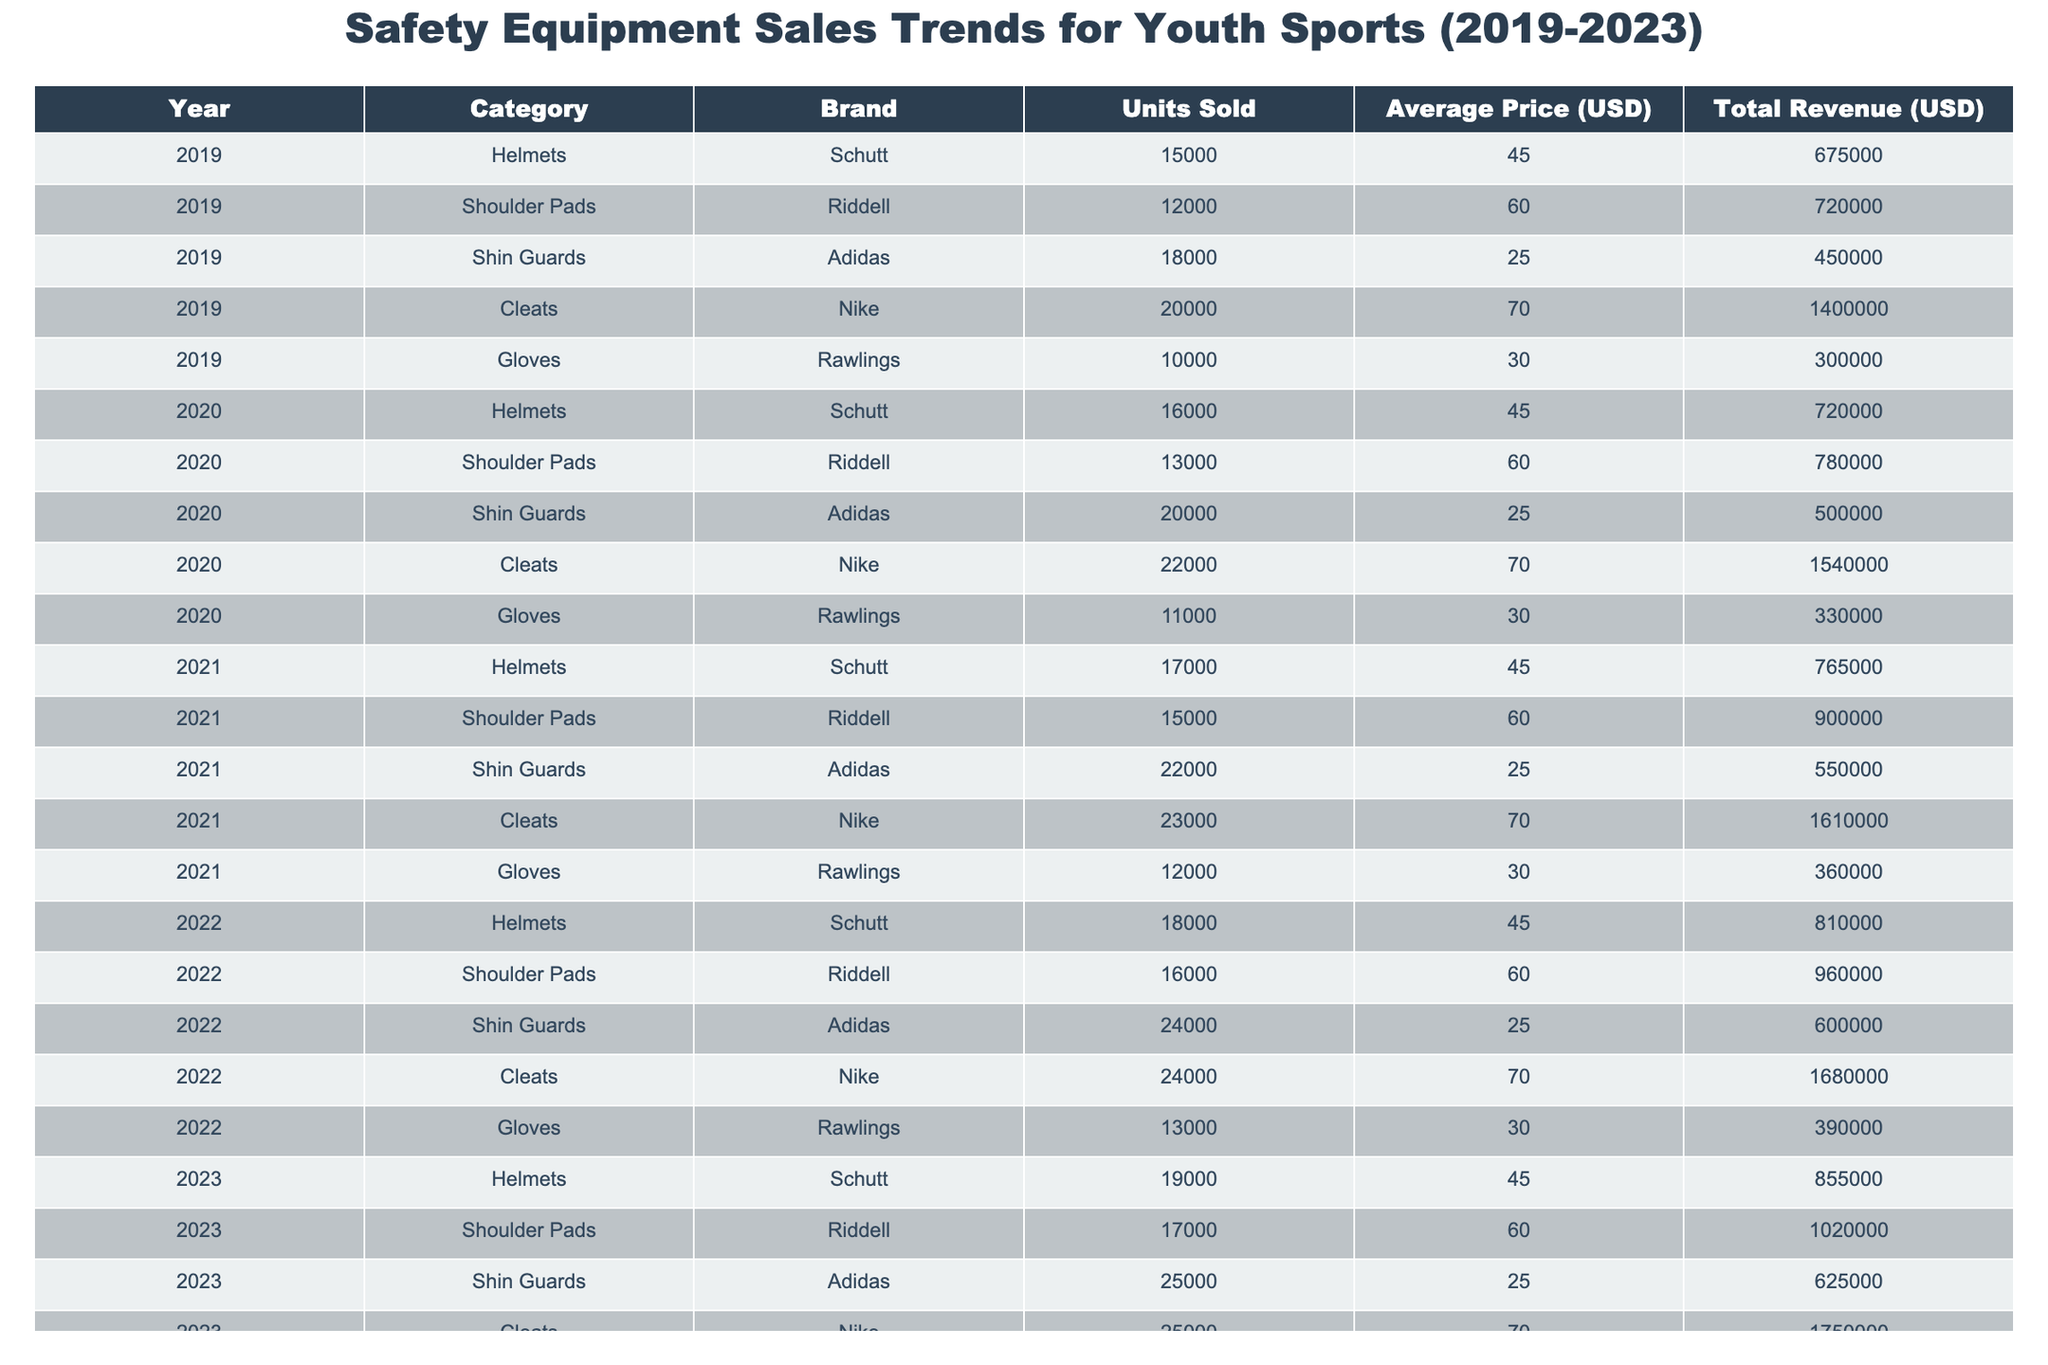What was the total revenue from Cleats in 2022? From the table, we can directly look at the row for Cleats under the year 2022, which shows a total revenue of 1,680,000 USD.
Answer: 1,680,000 USD Which brand sold the most Shin Guards in 2023? The table shows that Adidas sold 25,000 units of Shin Guards in 2023, which is the highest among all brands listed.
Answer: Adidas What is the average price of Shoulder Pads sold over the 5 years? To find the average price, we take the prices for Shoulder Pads from each year: 60.00 (2019) + 60.00 (2020) + 60.00 (2021) + 60.00 (2022) + 60.00 (2023) = 300.00 USD, and then divide by 5 (the number of years): 300.00 / 5 = 60.00 USD.
Answer: 60.00 USD Did the sales of Gloves increase every year from 2019 to 2023? Looking at the sales figures in the table for Gloves, we see that they increased from 10,000 (2019) to 14,000 (2023), confirming that there has been a consistent increase in sales each year.
Answer: Yes What was the percentage increase in total revenue from Helmets from 2019 to 2023? To find the percentage increase, we calculate the difference in revenue between 2023 and 2019: 855,000 - 675,000 = 180,000. Then divide by the 2019 revenue: 180,000 / 675,000 = 0.2667. Finally, multiply by 100 to convert to percentage: 0.2667 * 100 = 26.67%.
Answer: 26.67% Which year had the highest total sales for Cleats and what was the amount? By examining the Cleats row across all years, we see that the highest sales occurred in 2023 with 25,000 units sold.
Answer: 2023, 25,000 units What is the total number of Helmets sold from 2019 to 2023? Adding the units sold for Helmets over the 5 years: 15,000 (2019) + 16,000 (2020) + 17,000 (2021) + 18,000 (2022) + 19,000 (2023) = 85,000.
Answer: 85,000 Is the total revenue from all categories in 2020 greater than in 2019? For 2019, the total revenue is 675,000 (Helmets) + 720,000 (Shoulder Pads) + 450,000 (Shin Guards) + 1,400,000 (Cleats) + 300,000 (Gloves) = 3,545,000. For 2020, the total revenue is 720,000 (Helmets) + 780,000 (Shoulder Pads) + 500,000 (Shin Guards) + 1,540,000 (Cleats) + 330,000 (Gloves) = 3,870,000. Thus, 3,870,000 is greater than 3,545,000.
Answer: Yes What is the difference in units sold for Shin Guards between 2022 and 2021? The units sold for Shin Guards in 2022 is 24,000 and in 2021 is 22,000. The difference is 24,000 - 22,000 = 2,000 units.
Answer: 2,000 units Which category experienced the highest increase in units sold from 2019 to 2023? By looking at the changes over the years: Helmets increased from 15,000 to 19,000 (+4,000), Shoulder Pads from 12,000 to 17,000 (+5,000), Shin Guards from 18,000 to 25,000 (+7,000), Cleats from 20,000 to 25,000 (+5,000), and Gloves from 10,000 to 14,000 (+4,000). The highest increase is in Shin Guards with 7,000 additional units sold.
Answer: Shin Guards, 7,000 units 